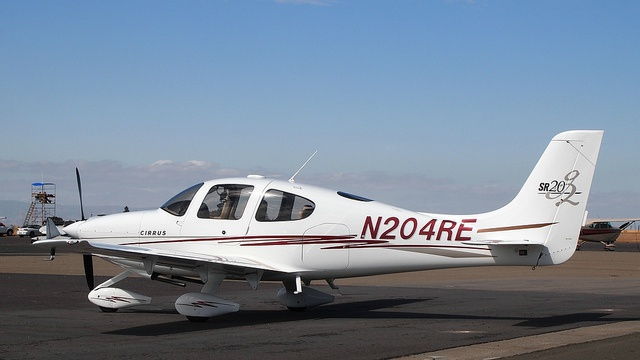Describe the objects in this image and their specific colors. I can see a airplane in gray, lightgray, black, and darkgray tones in this image. 